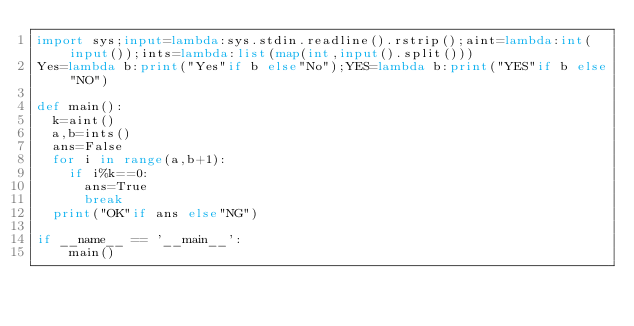<code> <loc_0><loc_0><loc_500><loc_500><_Python_>import sys;input=lambda:sys.stdin.readline().rstrip();aint=lambda:int(input());ints=lambda:list(map(int,input().split()))
Yes=lambda b:print("Yes"if b else"No");YES=lambda b:print("YES"if b else"NO")

def main():
  k=aint()
  a,b=ints()
  ans=False
  for i in range(a,b+1):
    if i%k==0:
      ans=True
      break
  print("OK"if ans else"NG")

if __name__ == '__main__':
    main()</code> 